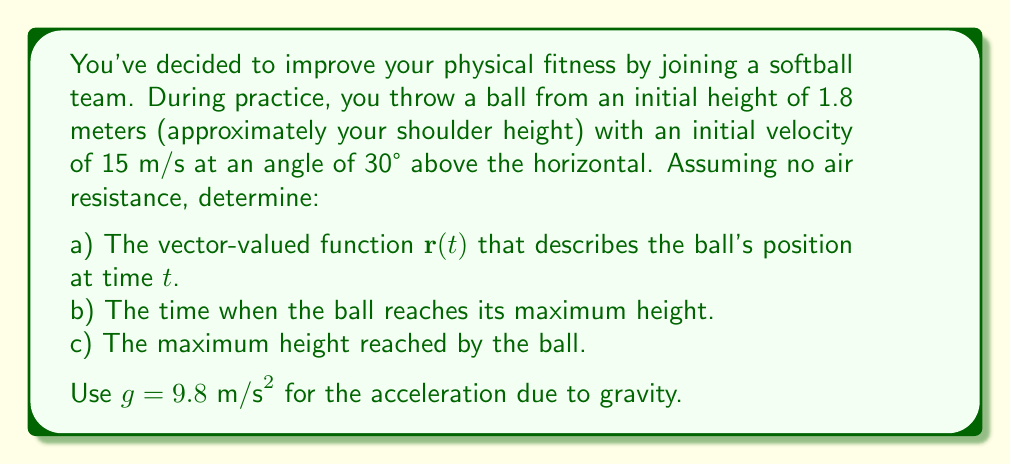Can you answer this question? Let's approach this step-by-step:

1) First, we need to set up our coordinate system. Let's use:
   - $x$-axis: horizontal direction of the throw
   - $y$-axis: vertical direction
   - Origin: point of release

2) The vector-valued function $\mathbf{r}(t)$ will have two components: $x(t)$ and $y(t)$.

3) For the $x$-component:
   - Initial velocity in x-direction: $v_{0x} = 15 \cos(30°) = 15 \cdot \frac{\sqrt{3}}{2} \approx 12.99 \text{ m/s}$
   - No acceleration in x-direction
   - $x(t) = v_{0x}t = 15 \frac{\sqrt{3}}{2}t$

4) For the $y$-component:
   - Initial velocity in y-direction: $v_{0y} = 15 \sin(30°) = 15 \cdot \frac{1}{2} = 7.5 \text{ m/s}$
   - Initial height: 1.8 m
   - Acceleration: $-g = -9.8 \text{ m/s}^2$
   - $y(t) = 1.8 + 7.5t - \frac{1}{2}(9.8)t^2 = 1.8 + 7.5t - 4.9t^2$

5) Therefore, the vector-valued function is:

   $$\mathbf{r}(t) = \left(15 \frac{\sqrt{3}}{2}t, 1.8 + 7.5t - 4.9t^2\right)$$

6) To find the time of maximum height:
   - The y-velocity at the highest point is zero
   - $v_y(t) = 7.5 - 9.8t = 0$
   - Solving this: $t = \frac{7.5}{9.8} \approx 0.77 \text{ seconds}$

7) To find the maximum height:
   - Substitute $t \approx 0.77$ into the $y(t)$ function:
   - $y(0.77) = 1.8 + 7.5(0.77) - 4.9(0.77)^2 \approx 4.68 \text{ meters}$
Answer: a) $\mathbf{r}(t) = \left(15 \frac{\sqrt{3}}{2}t, 1.8 + 7.5t - 4.9t^2\right)$

b) The ball reaches its maximum height at $t \approx 0.77$ seconds.

c) The maximum height reached by the ball is approximately 4.68 meters. 